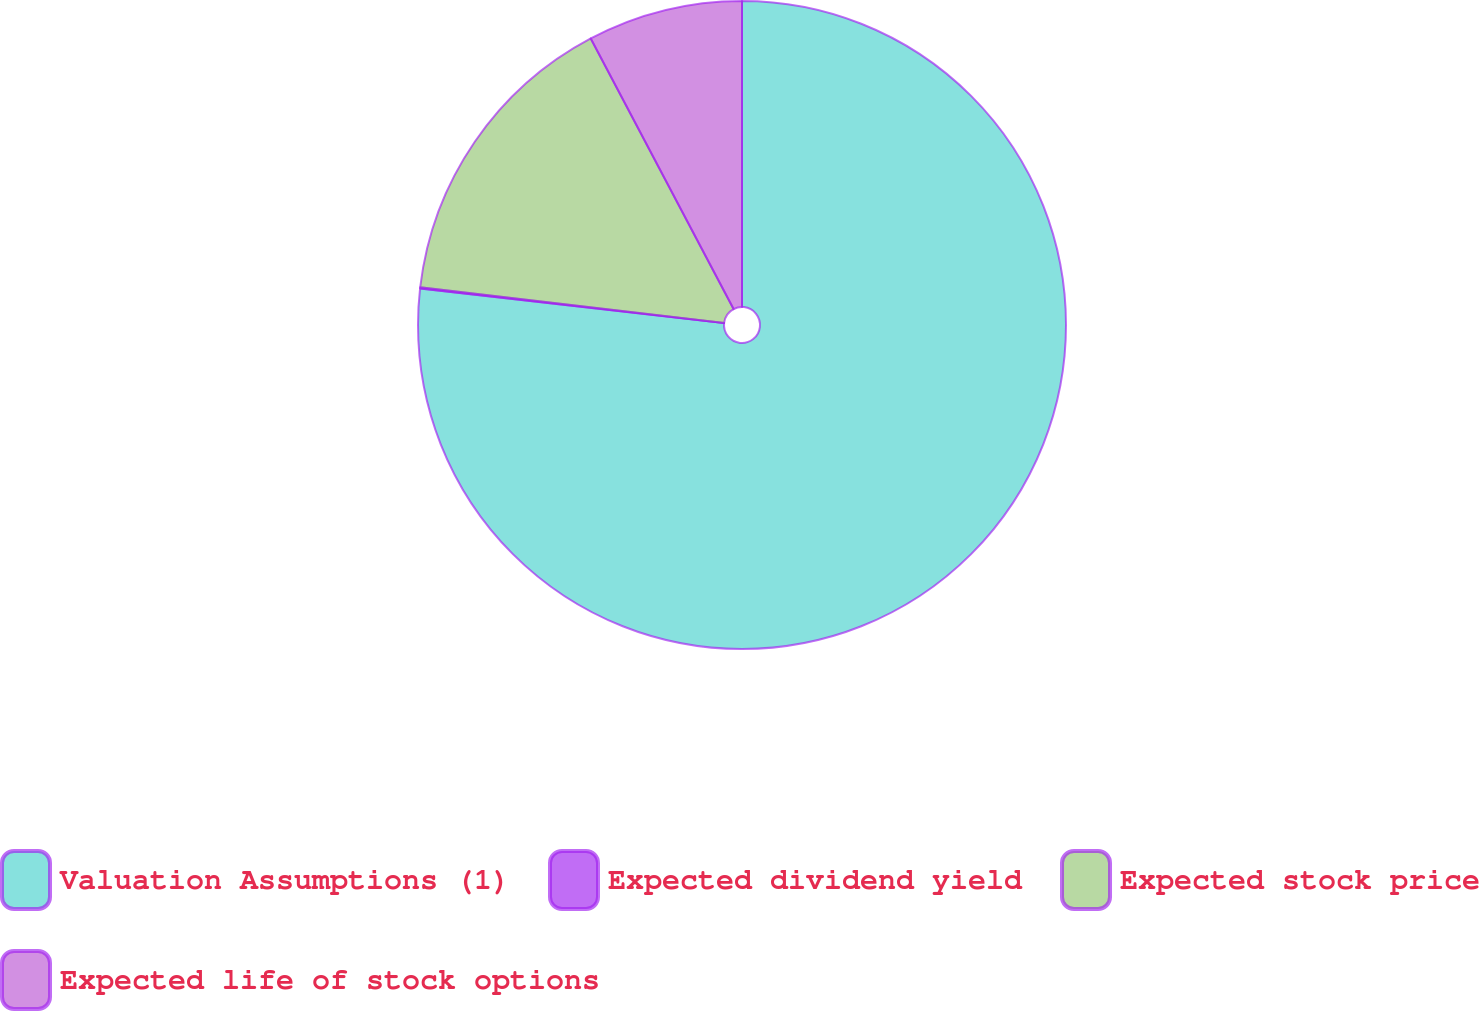<chart> <loc_0><loc_0><loc_500><loc_500><pie_chart><fcel>Valuation Assumptions (1)<fcel>Expected dividend yield<fcel>Expected stock price<fcel>Expected life of stock options<nl><fcel>76.8%<fcel>0.06%<fcel>15.41%<fcel>7.73%<nl></chart> 